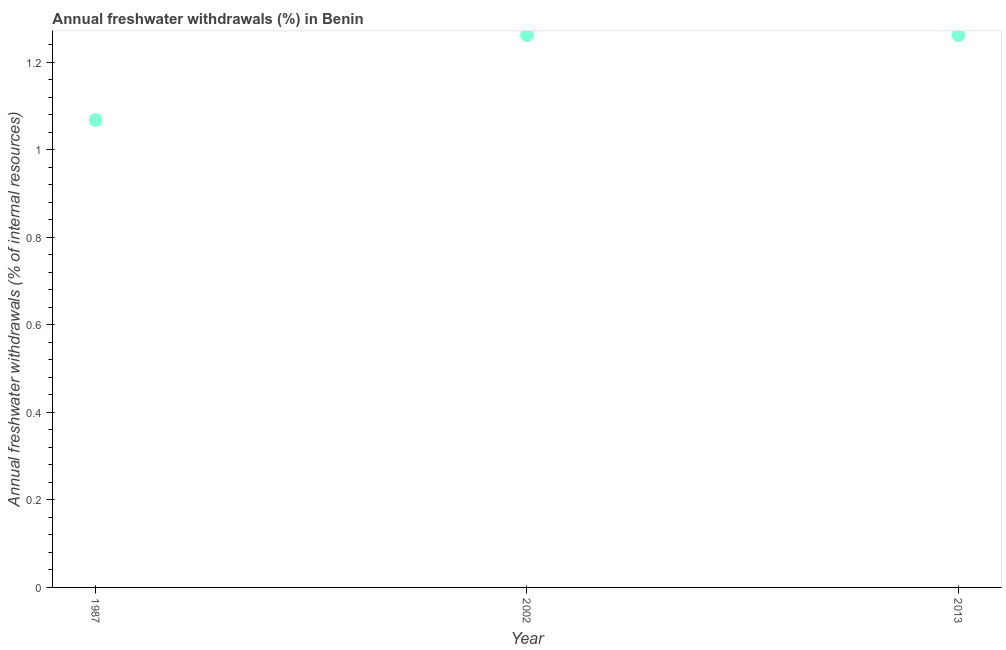What is the annual freshwater withdrawals in 2013?
Give a very brief answer. 1.26. Across all years, what is the maximum annual freshwater withdrawals?
Make the answer very short. 1.26. Across all years, what is the minimum annual freshwater withdrawals?
Your answer should be very brief. 1.07. In which year was the annual freshwater withdrawals maximum?
Make the answer very short. 2002. In which year was the annual freshwater withdrawals minimum?
Give a very brief answer. 1987. What is the sum of the annual freshwater withdrawals?
Keep it short and to the point. 3.59. What is the difference between the annual freshwater withdrawals in 1987 and 2013?
Provide a succinct answer. -0.19. What is the average annual freshwater withdrawals per year?
Keep it short and to the point. 1.2. What is the median annual freshwater withdrawals?
Offer a terse response. 1.26. Do a majority of the years between 1987 and 2002 (inclusive) have annual freshwater withdrawals greater than 0.12 %?
Make the answer very short. Yes. What is the ratio of the annual freshwater withdrawals in 2002 to that in 2013?
Ensure brevity in your answer.  1. Is the annual freshwater withdrawals in 1987 less than that in 2002?
Ensure brevity in your answer.  Yes. What is the difference between the highest and the second highest annual freshwater withdrawals?
Keep it short and to the point. 0. What is the difference between the highest and the lowest annual freshwater withdrawals?
Make the answer very short. 0.19. Does the annual freshwater withdrawals monotonically increase over the years?
Ensure brevity in your answer.  No. How many dotlines are there?
Your answer should be compact. 1. How many years are there in the graph?
Keep it short and to the point. 3. What is the difference between two consecutive major ticks on the Y-axis?
Provide a succinct answer. 0.2. What is the title of the graph?
Provide a succinct answer. Annual freshwater withdrawals (%) in Benin. What is the label or title of the X-axis?
Your answer should be very brief. Year. What is the label or title of the Y-axis?
Offer a terse response. Annual freshwater withdrawals (% of internal resources). What is the Annual freshwater withdrawals (% of internal resources) in 1987?
Your answer should be compact. 1.07. What is the Annual freshwater withdrawals (% of internal resources) in 2002?
Make the answer very short. 1.26. What is the Annual freshwater withdrawals (% of internal resources) in 2013?
Give a very brief answer. 1.26. What is the difference between the Annual freshwater withdrawals (% of internal resources) in 1987 and 2002?
Provide a short and direct response. -0.19. What is the difference between the Annual freshwater withdrawals (% of internal resources) in 1987 and 2013?
Your answer should be very brief. -0.19. What is the difference between the Annual freshwater withdrawals (% of internal resources) in 2002 and 2013?
Provide a succinct answer. 0. What is the ratio of the Annual freshwater withdrawals (% of internal resources) in 1987 to that in 2002?
Your response must be concise. 0.85. What is the ratio of the Annual freshwater withdrawals (% of internal resources) in 1987 to that in 2013?
Give a very brief answer. 0.85. 